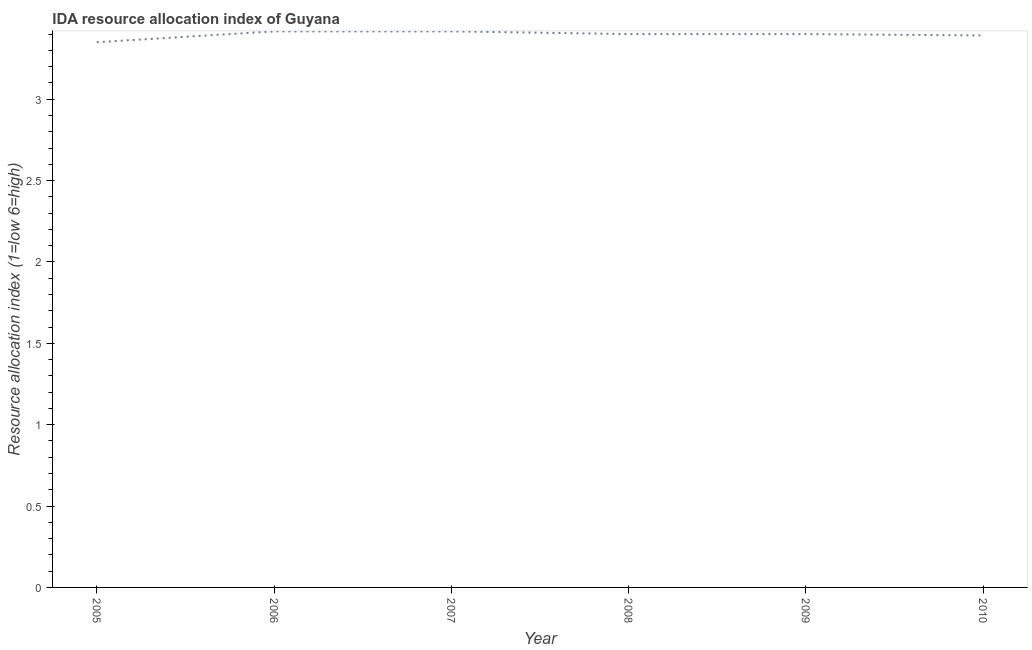What is the ida resource allocation index in 2010?
Provide a short and direct response. 3.39. Across all years, what is the maximum ida resource allocation index?
Your answer should be very brief. 3.42. Across all years, what is the minimum ida resource allocation index?
Ensure brevity in your answer.  3.35. In which year was the ida resource allocation index maximum?
Provide a succinct answer. 2006. What is the sum of the ida resource allocation index?
Ensure brevity in your answer.  20.38. What is the difference between the ida resource allocation index in 2007 and 2008?
Provide a succinct answer. 0.02. What is the average ida resource allocation index per year?
Your answer should be compact. 3.4. What is the median ida resource allocation index?
Give a very brief answer. 3.4. What is the ratio of the ida resource allocation index in 2009 to that in 2010?
Provide a succinct answer. 1. Is the ida resource allocation index in 2006 less than that in 2010?
Your answer should be very brief. No. Is the difference between the ida resource allocation index in 2008 and 2009 greater than the difference between any two years?
Your answer should be very brief. No. What is the difference between the highest and the second highest ida resource allocation index?
Give a very brief answer. 0. What is the difference between the highest and the lowest ida resource allocation index?
Your answer should be very brief. 0.07. Does the ida resource allocation index monotonically increase over the years?
Ensure brevity in your answer.  No. How many lines are there?
Give a very brief answer. 1. How many years are there in the graph?
Keep it short and to the point. 6. What is the difference between two consecutive major ticks on the Y-axis?
Provide a short and direct response. 0.5. Are the values on the major ticks of Y-axis written in scientific E-notation?
Keep it short and to the point. No. Does the graph contain grids?
Your answer should be very brief. No. What is the title of the graph?
Provide a succinct answer. IDA resource allocation index of Guyana. What is the label or title of the X-axis?
Keep it short and to the point. Year. What is the label or title of the Y-axis?
Provide a succinct answer. Resource allocation index (1=low 6=high). What is the Resource allocation index (1=low 6=high) in 2005?
Keep it short and to the point. 3.35. What is the Resource allocation index (1=low 6=high) in 2006?
Keep it short and to the point. 3.42. What is the Resource allocation index (1=low 6=high) in 2007?
Your answer should be compact. 3.42. What is the Resource allocation index (1=low 6=high) of 2008?
Give a very brief answer. 3.4. What is the Resource allocation index (1=low 6=high) of 2009?
Your response must be concise. 3.4. What is the Resource allocation index (1=low 6=high) of 2010?
Your answer should be very brief. 3.39. What is the difference between the Resource allocation index (1=low 6=high) in 2005 and 2006?
Your answer should be very brief. -0.07. What is the difference between the Resource allocation index (1=low 6=high) in 2005 and 2007?
Your answer should be compact. -0.07. What is the difference between the Resource allocation index (1=low 6=high) in 2005 and 2009?
Give a very brief answer. -0.05. What is the difference between the Resource allocation index (1=low 6=high) in 2005 and 2010?
Keep it short and to the point. -0.04. What is the difference between the Resource allocation index (1=low 6=high) in 2006 and 2008?
Provide a short and direct response. 0.02. What is the difference between the Resource allocation index (1=low 6=high) in 2006 and 2009?
Offer a very short reply. 0.02. What is the difference between the Resource allocation index (1=low 6=high) in 2006 and 2010?
Offer a terse response. 0.03. What is the difference between the Resource allocation index (1=low 6=high) in 2007 and 2008?
Ensure brevity in your answer.  0.02. What is the difference between the Resource allocation index (1=low 6=high) in 2007 and 2009?
Give a very brief answer. 0.02. What is the difference between the Resource allocation index (1=low 6=high) in 2007 and 2010?
Keep it short and to the point. 0.03. What is the difference between the Resource allocation index (1=low 6=high) in 2008 and 2010?
Provide a short and direct response. 0.01. What is the difference between the Resource allocation index (1=low 6=high) in 2009 and 2010?
Offer a very short reply. 0.01. What is the ratio of the Resource allocation index (1=low 6=high) in 2005 to that in 2008?
Ensure brevity in your answer.  0.98. What is the ratio of the Resource allocation index (1=low 6=high) in 2005 to that in 2010?
Provide a short and direct response. 0.99. What is the ratio of the Resource allocation index (1=low 6=high) in 2006 to that in 2007?
Ensure brevity in your answer.  1. What is the ratio of the Resource allocation index (1=low 6=high) in 2006 to that in 2009?
Your answer should be very brief. 1. What is the ratio of the Resource allocation index (1=low 6=high) in 2006 to that in 2010?
Provide a succinct answer. 1.01. What is the ratio of the Resource allocation index (1=low 6=high) in 2008 to that in 2009?
Your answer should be compact. 1. What is the ratio of the Resource allocation index (1=low 6=high) in 2008 to that in 2010?
Offer a very short reply. 1. What is the ratio of the Resource allocation index (1=low 6=high) in 2009 to that in 2010?
Your answer should be compact. 1. 